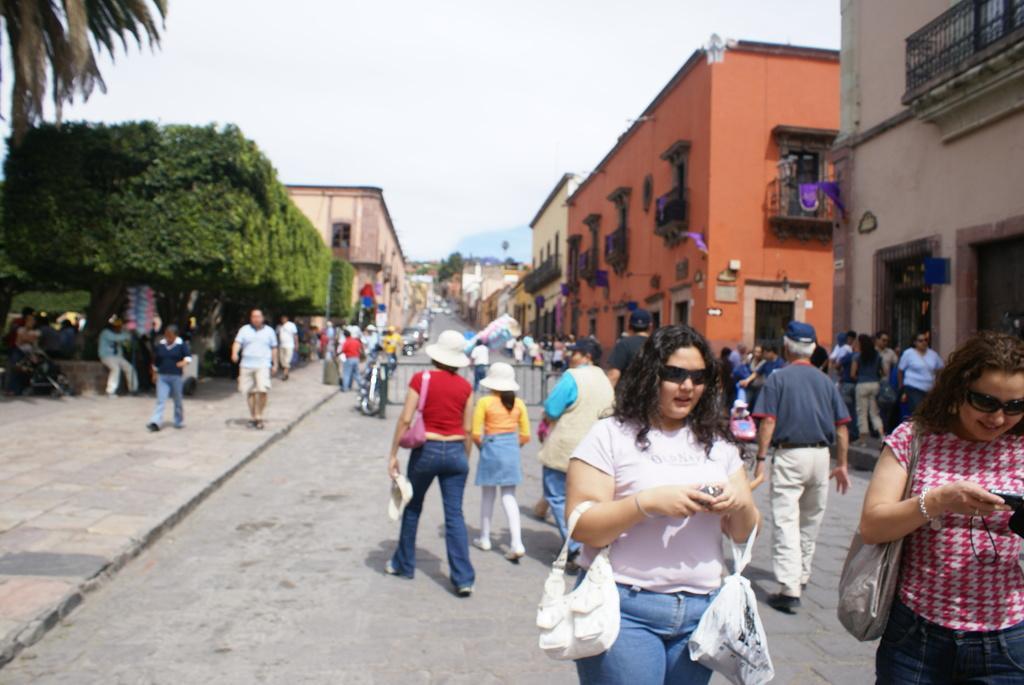Describe this image in one or two sentences. In this image I can see a woman wearing white t shirt, blue jeans is standing and holding two bags in her hand and I can see another woman wearing red and white shirt and blue jeans is standing and holding a bag and a mobile in her hand. In the background I can see few other persons walking on the road, the railing, few persons standing on the sidewalk, few vehicles on the road, few buildings on the both sides of the road, few trees and the sky. 